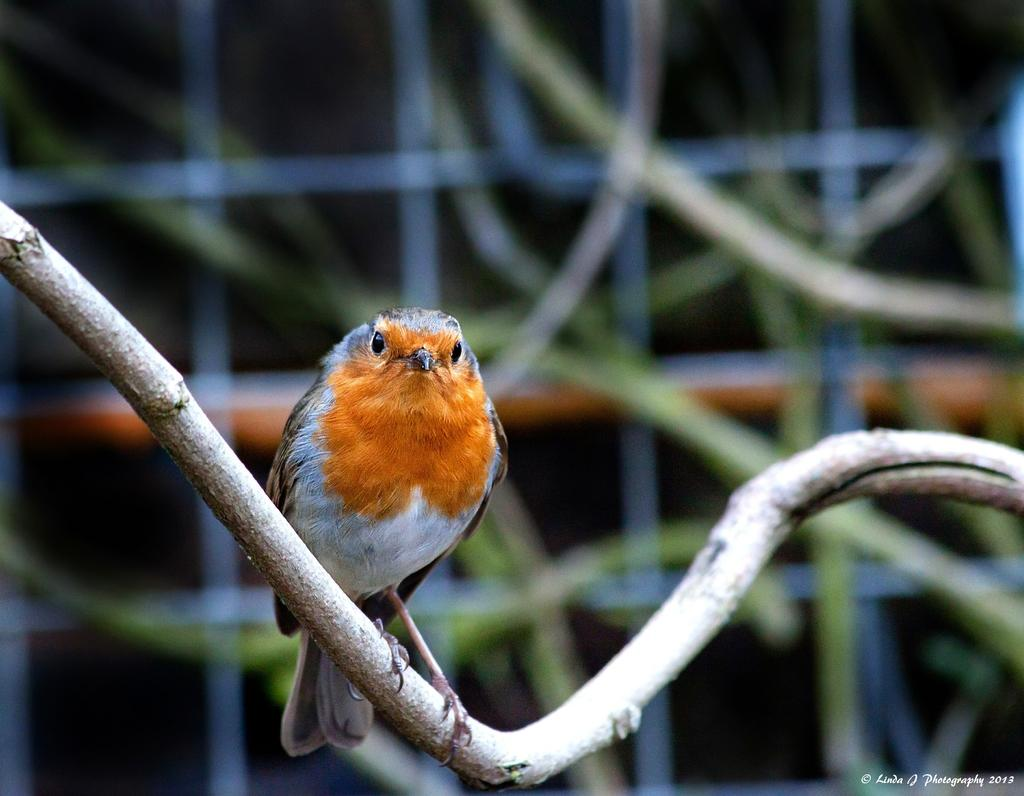What type of animal is in the image? There is a bird in the image. Where is the bird located? The bird is standing on a branch. What can be observed about the background of the image? The background of the image is blurred. Is there any additional marking on the image? Yes, there is a watermark on the image. Can you describe the volcano in the image? There is no volcano present in the image; it features a bird standing on a branch. What type of beast is interacting with the bird in the image? There is no beast present in the image; it only features a bird standing on a branch. 